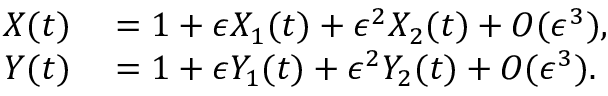Convert formula to latex. <formula><loc_0><loc_0><loc_500><loc_500>\begin{array} { r l } { X ( t ) } & = 1 + \epsilon X _ { 1 } ( t ) + \epsilon ^ { 2 } X _ { 2 } ( t ) + O ( \epsilon ^ { 3 } ) , } \\ { Y ( t ) } & = 1 + \epsilon Y _ { 1 } ( t ) + \epsilon ^ { 2 } Y _ { 2 } ( t ) + O ( \epsilon ^ { 3 } ) . } \end{array}</formula> 